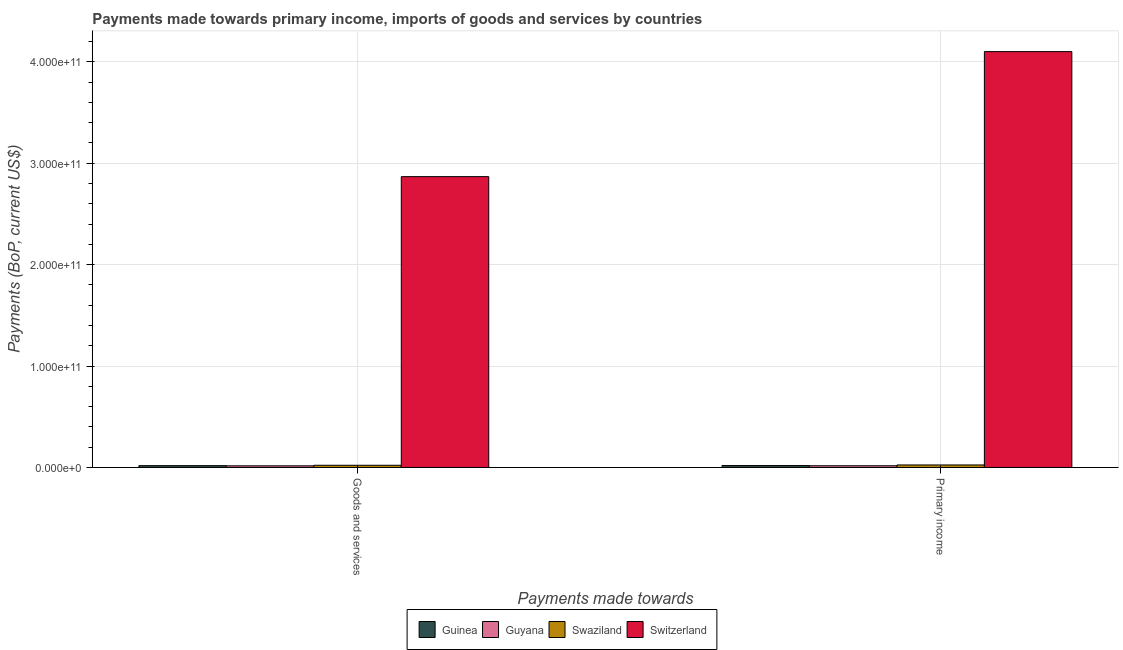How many different coloured bars are there?
Give a very brief answer. 4. How many groups of bars are there?
Keep it short and to the point. 2. Are the number of bars per tick equal to the number of legend labels?
Keep it short and to the point. Yes. What is the label of the 1st group of bars from the left?
Offer a very short reply. Goods and services. What is the payments made towards goods and services in Guyana?
Make the answer very short. 1.65e+09. Across all countries, what is the maximum payments made towards goods and services?
Provide a short and direct response. 2.87e+11. Across all countries, what is the minimum payments made towards goods and services?
Ensure brevity in your answer.  1.65e+09. In which country was the payments made towards goods and services maximum?
Your answer should be compact. Switzerland. In which country was the payments made towards goods and services minimum?
Make the answer very short. Guyana. What is the total payments made towards primary income in the graph?
Your response must be concise. 4.16e+11. What is the difference between the payments made towards goods and services in Swaziland and that in Guinea?
Ensure brevity in your answer.  3.70e+08. What is the difference between the payments made towards goods and services in Guinea and the payments made towards primary income in Switzerland?
Provide a succinct answer. -4.08e+11. What is the average payments made towards goods and services per country?
Ensure brevity in your answer.  7.31e+1. What is the difference between the payments made towards goods and services and payments made towards primary income in Switzerland?
Provide a short and direct response. -1.23e+11. What is the ratio of the payments made towards goods and services in Guinea to that in Guyana?
Provide a short and direct response. 1.1. Is the payments made towards goods and services in Guyana less than that in Guinea?
Your response must be concise. Yes. In how many countries, is the payments made towards goods and services greater than the average payments made towards goods and services taken over all countries?
Your answer should be compact. 1. What does the 1st bar from the left in Goods and services represents?
Your response must be concise. Guinea. What does the 3rd bar from the right in Primary income represents?
Your answer should be compact. Guyana. How many bars are there?
Make the answer very short. 8. Are all the bars in the graph horizontal?
Ensure brevity in your answer.  No. How many countries are there in the graph?
Make the answer very short. 4. What is the difference between two consecutive major ticks on the Y-axis?
Keep it short and to the point. 1.00e+11. Does the graph contain grids?
Your answer should be compact. Yes. Where does the legend appear in the graph?
Provide a short and direct response. Bottom center. How many legend labels are there?
Give a very brief answer. 4. How are the legend labels stacked?
Your answer should be very brief. Horizontal. What is the title of the graph?
Offer a very short reply. Payments made towards primary income, imports of goods and services by countries. What is the label or title of the X-axis?
Provide a succinct answer. Payments made towards. What is the label or title of the Y-axis?
Make the answer very short. Payments (BoP, current US$). What is the Payments (BoP, current US$) of Guinea in Goods and services?
Offer a very short reply. 1.81e+09. What is the Payments (BoP, current US$) of Guyana in Goods and services?
Your answer should be compact. 1.65e+09. What is the Payments (BoP, current US$) in Swaziland in Goods and services?
Provide a short and direct response. 2.18e+09. What is the Payments (BoP, current US$) of Switzerland in Goods and services?
Give a very brief answer. 2.87e+11. What is the Payments (BoP, current US$) of Guinea in Primary income?
Your response must be concise. 1.91e+09. What is the Payments (BoP, current US$) of Guyana in Primary income?
Offer a very short reply. 1.70e+09. What is the Payments (BoP, current US$) in Swaziland in Primary income?
Ensure brevity in your answer.  2.48e+09. What is the Payments (BoP, current US$) of Switzerland in Primary income?
Your answer should be very brief. 4.10e+11. Across all Payments made towards, what is the maximum Payments (BoP, current US$) in Guinea?
Provide a succinct answer. 1.91e+09. Across all Payments made towards, what is the maximum Payments (BoP, current US$) in Guyana?
Your response must be concise. 1.70e+09. Across all Payments made towards, what is the maximum Payments (BoP, current US$) in Swaziland?
Provide a succinct answer. 2.48e+09. Across all Payments made towards, what is the maximum Payments (BoP, current US$) of Switzerland?
Your answer should be very brief. 4.10e+11. Across all Payments made towards, what is the minimum Payments (BoP, current US$) in Guinea?
Make the answer very short. 1.81e+09. Across all Payments made towards, what is the minimum Payments (BoP, current US$) in Guyana?
Offer a very short reply. 1.65e+09. Across all Payments made towards, what is the minimum Payments (BoP, current US$) in Swaziland?
Ensure brevity in your answer.  2.18e+09. Across all Payments made towards, what is the minimum Payments (BoP, current US$) of Switzerland?
Provide a short and direct response. 2.87e+11. What is the total Payments (BoP, current US$) in Guinea in the graph?
Provide a short and direct response. 3.72e+09. What is the total Payments (BoP, current US$) in Guyana in the graph?
Provide a succinct answer. 3.35e+09. What is the total Payments (BoP, current US$) in Swaziland in the graph?
Your response must be concise. 4.66e+09. What is the total Payments (BoP, current US$) in Switzerland in the graph?
Offer a terse response. 6.97e+11. What is the difference between the Payments (BoP, current US$) in Guinea in Goods and services and that in Primary income?
Keep it short and to the point. -1.01e+08. What is the difference between the Payments (BoP, current US$) of Guyana in Goods and services and that in Primary income?
Provide a short and direct response. -5.61e+07. What is the difference between the Payments (BoP, current US$) in Swaziland in Goods and services and that in Primary income?
Your answer should be compact. -3.03e+08. What is the difference between the Payments (BoP, current US$) of Switzerland in Goods and services and that in Primary income?
Give a very brief answer. -1.23e+11. What is the difference between the Payments (BoP, current US$) in Guinea in Goods and services and the Payments (BoP, current US$) in Guyana in Primary income?
Offer a terse response. 1.06e+08. What is the difference between the Payments (BoP, current US$) of Guinea in Goods and services and the Payments (BoP, current US$) of Swaziland in Primary income?
Provide a succinct answer. -6.73e+08. What is the difference between the Payments (BoP, current US$) in Guinea in Goods and services and the Payments (BoP, current US$) in Switzerland in Primary income?
Offer a very short reply. -4.08e+11. What is the difference between the Payments (BoP, current US$) of Guyana in Goods and services and the Payments (BoP, current US$) of Swaziland in Primary income?
Offer a very short reply. -8.35e+08. What is the difference between the Payments (BoP, current US$) in Guyana in Goods and services and the Payments (BoP, current US$) in Switzerland in Primary income?
Provide a succinct answer. -4.08e+11. What is the difference between the Payments (BoP, current US$) in Swaziland in Goods and services and the Payments (BoP, current US$) in Switzerland in Primary income?
Your answer should be very brief. -4.08e+11. What is the average Payments (BoP, current US$) in Guinea per Payments made towards?
Your response must be concise. 1.86e+09. What is the average Payments (BoP, current US$) in Guyana per Payments made towards?
Your answer should be very brief. 1.68e+09. What is the average Payments (BoP, current US$) in Swaziland per Payments made towards?
Keep it short and to the point. 2.33e+09. What is the average Payments (BoP, current US$) of Switzerland per Payments made towards?
Offer a terse response. 3.48e+11. What is the difference between the Payments (BoP, current US$) of Guinea and Payments (BoP, current US$) of Guyana in Goods and services?
Make the answer very short. 1.62e+08. What is the difference between the Payments (BoP, current US$) of Guinea and Payments (BoP, current US$) of Swaziland in Goods and services?
Make the answer very short. -3.70e+08. What is the difference between the Payments (BoP, current US$) of Guinea and Payments (BoP, current US$) of Switzerland in Goods and services?
Ensure brevity in your answer.  -2.85e+11. What is the difference between the Payments (BoP, current US$) of Guyana and Payments (BoP, current US$) of Swaziland in Goods and services?
Offer a terse response. -5.31e+08. What is the difference between the Payments (BoP, current US$) of Guyana and Payments (BoP, current US$) of Switzerland in Goods and services?
Your answer should be very brief. -2.85e+11. What is the difference between the Payments (BoP, current US$) of Swaziland and Payments (BoP, current US$) of Switzerland in Goods and services?
Provide a succinct answer. -2.85e+11. What is the difference between the Payments (BoP, current US$) in Guinea and Payments (BoP, current US$) in Guyana in Primary income?
Keep it short and to the point. 2.07e+08. What is the difference between the Payments (BoP, current US$) of Guinea and Payments (BoP, current US$) of Swaziland in Primary income?
Your answer should be very brief. -5.72e+08. What is the difference between the Payments (BoP, current US$) in Guinea and Payments (BoP, current US$) in Switzerland in Primary income?
Give a very brief answer. -4.08e+11. What is the difference between the Payments (BoP, current US$) in Guyana and Payments (BoP, current US$) in Swaziland in Primary income?
Provide a succinct answer. -7.78e+08. What is the difference between the Payments (BoP, current US$) of Guyana and Payments (BoP, current US$) of Switzerland in Primary income?
Keep it short and to the point. -4.08e+11. What is the difference between the Payments (BoP, current US$) in Swaziland and Payments (BoP, current US$) in Switzerland in Primary income?
Your answer should be compact. -4.08e+11. What is the ratio of the Payments (BoP, current US$) of Guinea in Goods and services to that in Primary income?
Make the answer very short. 0.95. What is the ratio of the Payments (BoP, current US$) in Guyana in Goods and services to that in Primary income?
Keep it short and to the point. 0.97. What is the ratio of the Payments (BoP, current US$) in Swaziland in Goods and services to that in Primary income?
Your answer should be compact. 0.88. What is the ratio of the Payments (BoP, current US$) in Switzerland in Goods and services to that in Primary income?
Ensure brevity in your answer.  0.7. What is the difference between the highest and the second highest Payments (BoP, current US$) in Guinea?
Your answer should be compact. 1.01e+08. What is the difference between the highest and the second highest Payments (BoP, current US$) of Guyana?
Your answer should be very brief. 5.61e+07. What is the difference between the highest and the second highest Payments (BoP, current US$) in Swaziland?
Your answer should be compact. 3.03e+08. What is the difference between the highest and the second highest Payments (BoP, current US$) of Switzerland?
Offer a terse response. 1.23e+11. What is the difference between the highest and the lowest Payments (BoP, current US$) of Guinea?
Keep it short and to the point. 1.01e+08. What is the difference between the highest and the lowest Payments (BoP, current US$) in Guyana?
Your answer should be very brief. 5.61e+07. What is the difference between the highest and the lowest Payments (BoP, current US$) of Swaziland?
Keep it short and to the point. 3.03e+08. What is the difference between the highest and the lowest Payments (BoP, current US$) of Switzerland?
Your response must be concise. 1.23e+11. 